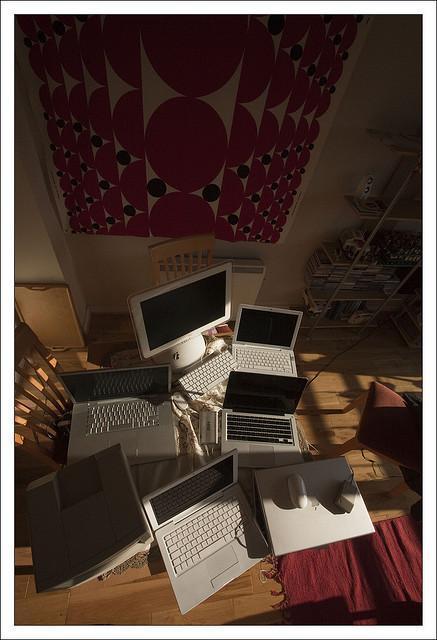How many tvs are there?
Give a very brief answer. 2. How many laptops are visible?
Give a very brief answer. 6. How many chairs are in the photo?
Give a very brief answer. 2. How many people can be seen?
Give a very brief answer. 0. 